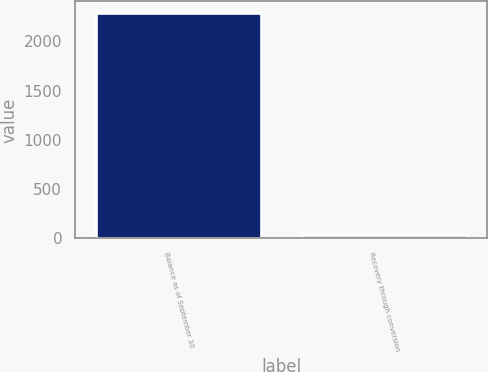<chart> <loc_0><loc_0><loc_500><loc_500><bar_chart><fcel>Balance as of September 30<fcel>Recovery through conversion<nl><fcel>2291<fcel>35<nl></chart> 